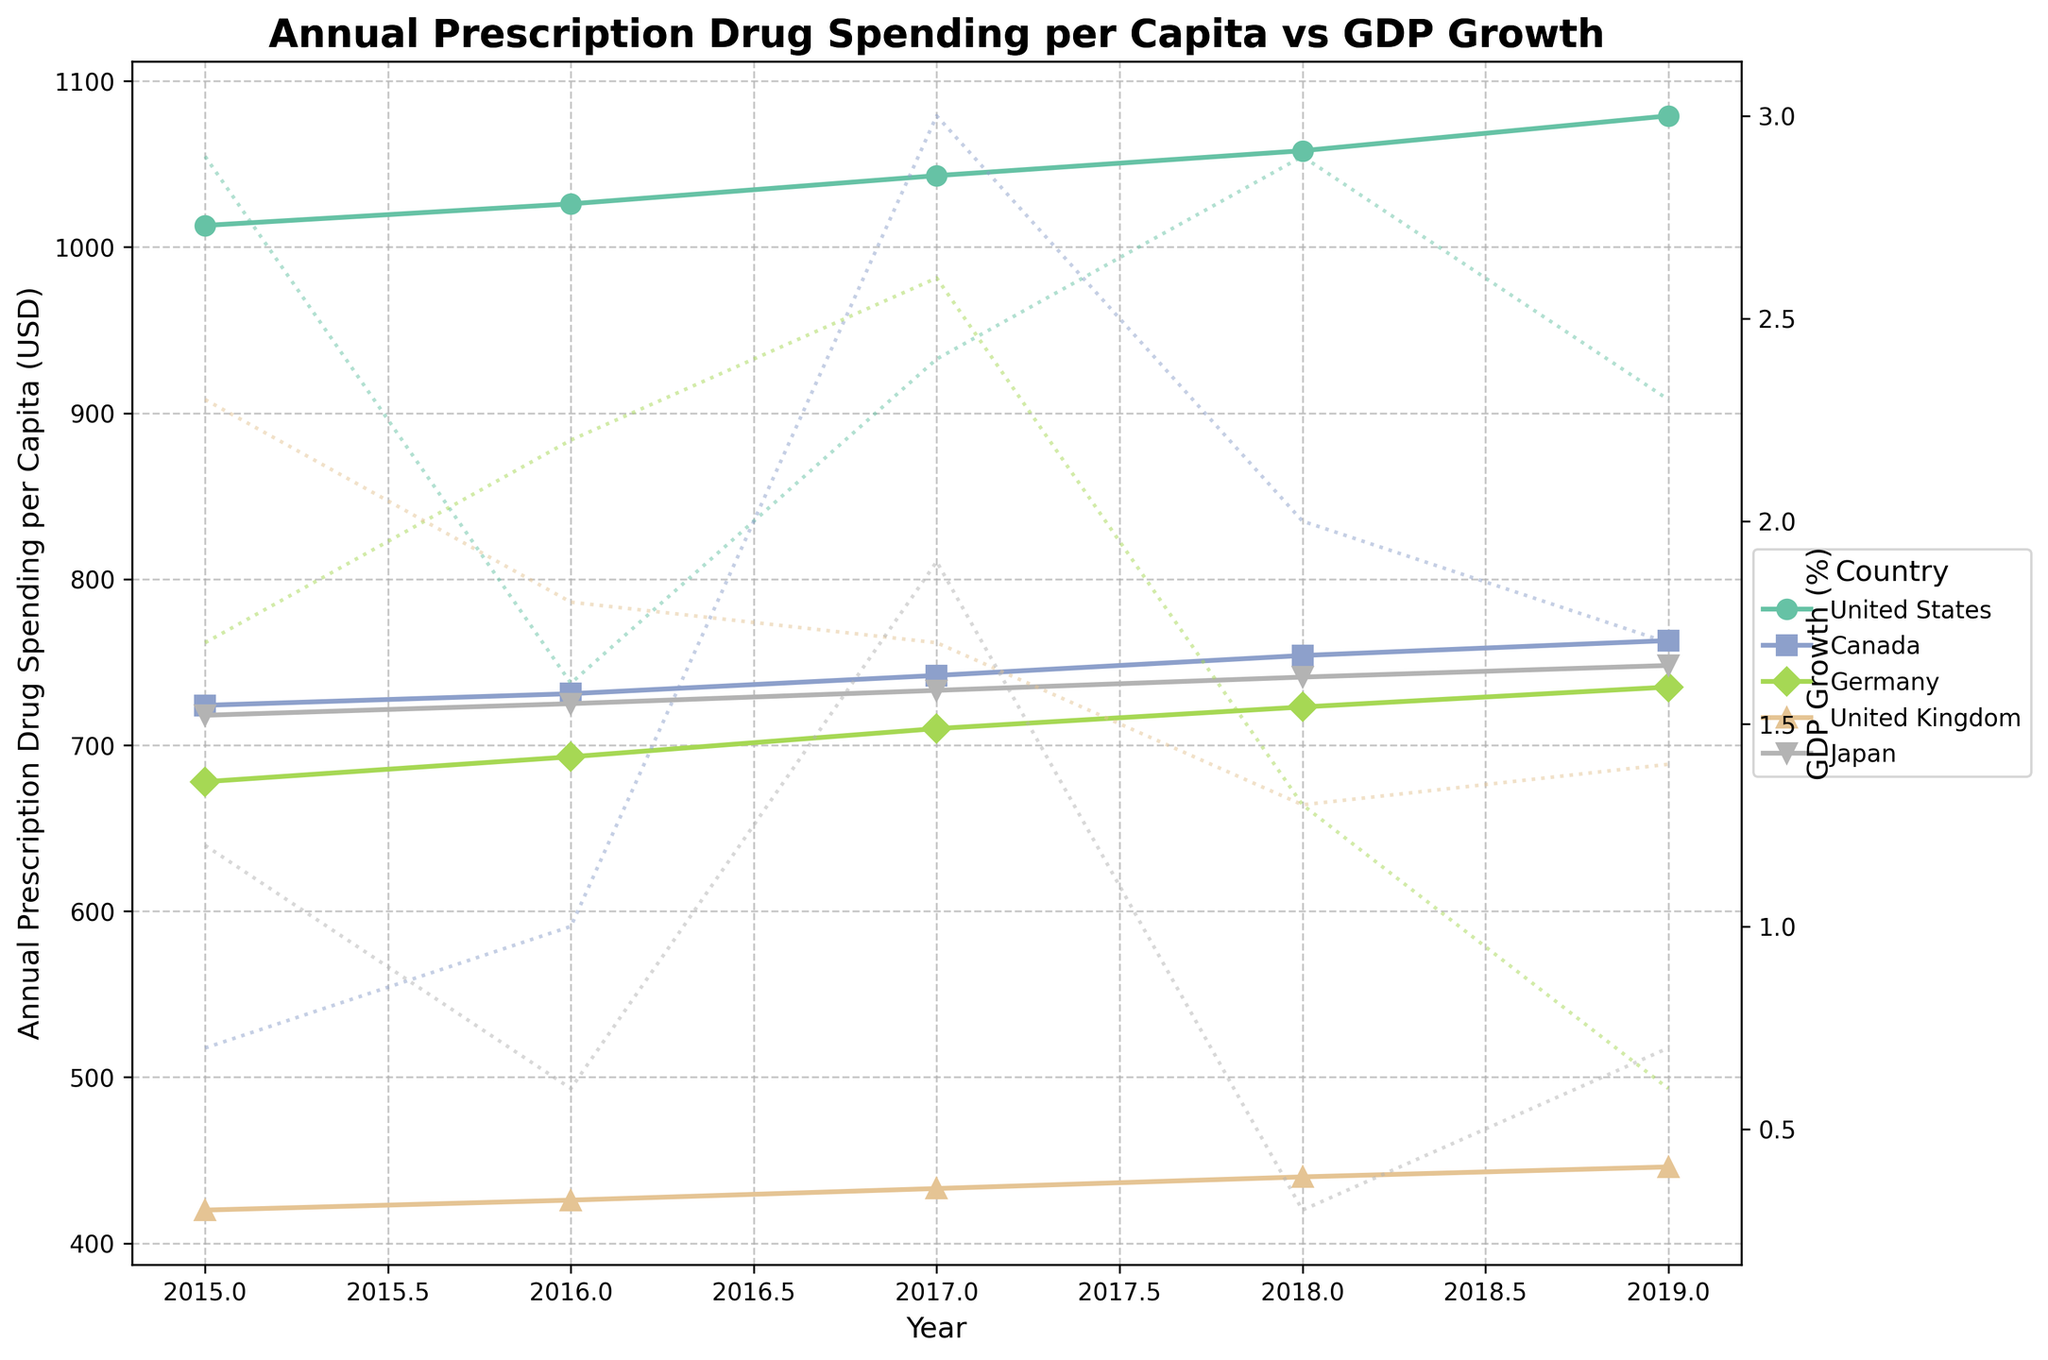What trend can be observed for Annual Prescription Drug Spending per Capita in the United States from 2015 to 2019? From 2015 to 2019, the Annual Prescription Drug Spending per Capita in the United States increased steadily. In 2015 it was $1013, and by 2019 it increased to $1079.
Answer: Increased steadily How does the United States' Annual Prescription Drug Spending per Capita in 2019 compare to that of Canada in the same year? In 2019, the United States had an Annual Prescription Drug Spending per Capita of $1079, whereas Canada had $763. The United States spent more compared to Canada.
Answer: The United States spent more Which country had the lowest Annual Prescription Drug Spending per Capita in 2015 and how much was it? In 2015, the United Kingdom had the lowest Annual Prescription Drug Spending per Capita, which was $420.
Answer: United Kingdom, $420 How did the GDP Growth (%) of Japan change from 2015 to 2019? From 2015 to 2019, Japan's GDP Growth (%) fluctuated. In 2015, it was 1.2%, then it decreased to 0.6% in 2016, rose to 1.9% in 2017, dropped to 0.3% in 2018, and finally rose slightly to 0.7% in 2019.
Answer: Fluctuated Which country had the highest GDP Growth (%) in 2017 and what was it? In 2017, Canada had the highest GDP Growth (%) at 3.0%.
Answer: Canada, 3.0% By how much did the Annual Prescription Drug Spending per Capita in Germany increase from 2016 to 2019? In 2016, Germany's Annual Prescription Drug Spending per Capita was $693. By 2019, it increased to $735. The increase is $735 - $693 = $42.
Answer: $42 Compare the overall trend of GDP Growth (%) and Annual Prescription Drug Spending per Capita in the United Kingdom from 2015 to 2019. Both the GDP Growth (%) and the Annual Prescription Drug Spending per Capita in the United Kingdom showed different trends. The GDP Growth (%) generally decreased from 2.3% in 2015 to 1.4% in 2019, while the Annual Prescription Drug Spending per Capita increased from $420 in 2015 to $446 in 2019.
Answer: Different trends Which two countries had a GDP Growth (%) of less than 1% in 2019, and what was their respective GDP Growth? In 2019, the countries with a GDP Growth (%) of less than 1% were Germany with 0.6% and Japan with 0.7%.
Answer: Germany, 0.6%; Japan, 0.7% What is the average Annual Prescription Drug Spending per Capita in the United Kingdom over the years 2015 to 2019? The Annual Prescription Drug Spending per Capita in the United Kingdom for the years 2015 to 2019 is $420, $426, $433, $440, and $446 respectively. The average is (420 + 426 + 433 + 440 + 446) / 5 = 433.
Answer: $433 